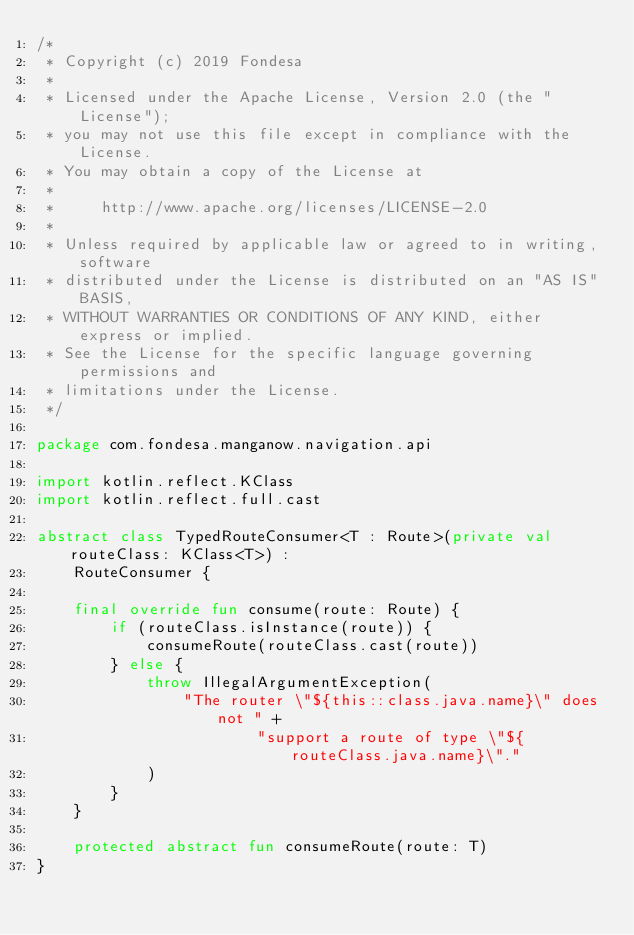<code> <loc_0><loc_0><loc_500><loc_500><_Kotlin_>/*
 * Copyright (c) 2019 Fondesa
 *
 * Licensed under the Apache License, Version 2.0 (the "License");
 * you may not use this file except in compliance with the License.
 * You may obtain a copy of the License at
 *
 *     http://www.apache.org/licenses/LICENSE-2.0
 *
 * Unless required by applicable law or agreed to in writing, software
 * distributed under the License is distributed on an "AS IS" BASIS,
 * WITHOUT WARRANTIES OR CONDITIONS OF ANY KIND, either express or implied.
 * See the License for the specific language governing permissions and
 * limitations under the License.
 */

package com.fondesa.manganow.navigation.api

import kotlin.reflect.KClass
import kotlin.reflect.full.cast

abstract class TypedRouteConsumer<T : Route>(private val routeClass: KClass<T>) :
    RouteConsumer {

    final override fun consume(route: Route) {
        if (routeClass.isInstance(route)) {
            consumeRoute(routeClass.cast(route))
        } else {
            throw IllegalArgumentException(
                "The router \"${this::class.java.name}\" does not " +
                        "support a route of type \"${routeClass.java.name}\"."
            )
        }
    }

    protected abstract fun consumeRoute(route: T)
}</code> 